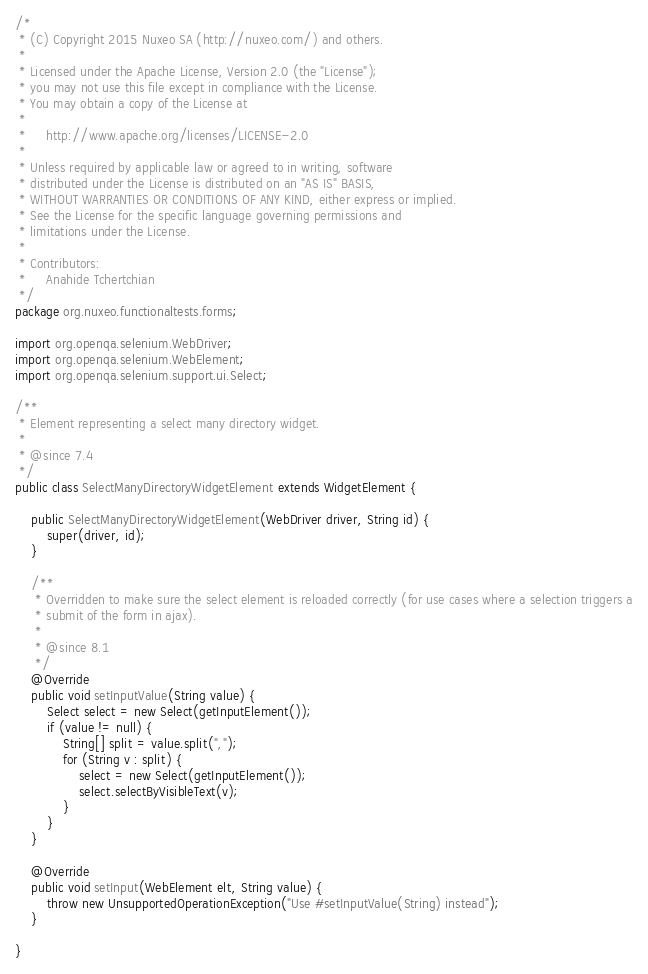<code> <loc_0><loc_0><loc_500><loc_500><_Java_>/*
 * (C) Copyright 2015 Nuxeo SA (http://nuxeo.com/) and others.
 *
 * Licensed under the Apache License, Version 2.0 (the "License");
 * you may not use this file except in compliance with the License.
 * You may obtain a copy of the License at
 *
 *     http://www.apache.org/licenses/LICENSE-2.0
 *
 * Unless required by applicable law or agreed to in writing, software
 * distributed under the License is distributed on an "AS IS" BASIS,
 * WITHOUT WARRANTIES OR CONDITIONS OF ANY KIND, either express or implied.
 * See the License for the specific language governing permissions and
 * limitations under the License.
 *
 * Contributors:
 *     Anahide Tchertchian
 */
package org.nuxeo.functionaltests.forms;

import org.openqa.selenium.WebDriver;
import org.openqa.selenium.WebElement;
import org.openqa.selenium.support.ui.Select;

/**
 * Element representing a select many directory widget.
 *
 * @since 7.4
 */
public class SelectManyDirectoryWidgetElement extends WidgetElement {

    public SelectManyDirectoryWidgetElement(WebDriver driver, String id) {
        super(driver, id);
    }

    /**
     * Overridden to make sure the select element is reloaded correctly (for use cases where a selection triggers a
     * submit of the form in ajax).
     *
     * @since 8.1
     */
    @Override
    public void setInputValue(String value) {
        Select select = new Select(getInputElement());
        if (value != null) {
            String[] split = value.split(",");
            for (String v : split) {
                select = new Select(getInputElement());
                select.selectByVisibleText(v);
            }
        }
    }

    @Override
    public void setInput(WebElement elt, String value) {
        throw new UnsupportedOperationException("Use #setInputValue(String) instead");
    }

}
</code> 